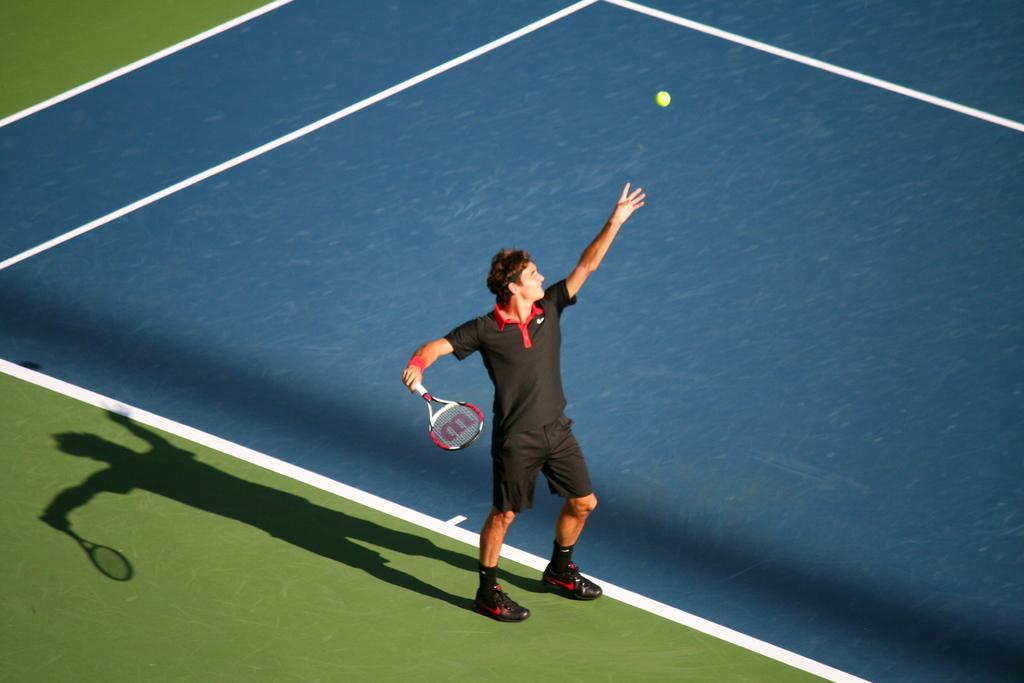What is the main subject of the image? There is a tennis player in the image. What is the tennis player standing on? The tennis player is standing on the ground. What is the tennis player holding? The tennis player is holding a tennis racket. What is happening with the tennis ball in the image? There is a tennis ball in the air in front of the player. What type of area is visible in the image? There is a tennis court visible in the image. How many passengers are visible in the image? There are no passengers present in the image; it features a tennis player on a tennis court. Is there a prison visible in the image? There is no prison present in the image; it features a tennis player on a tennis court. 